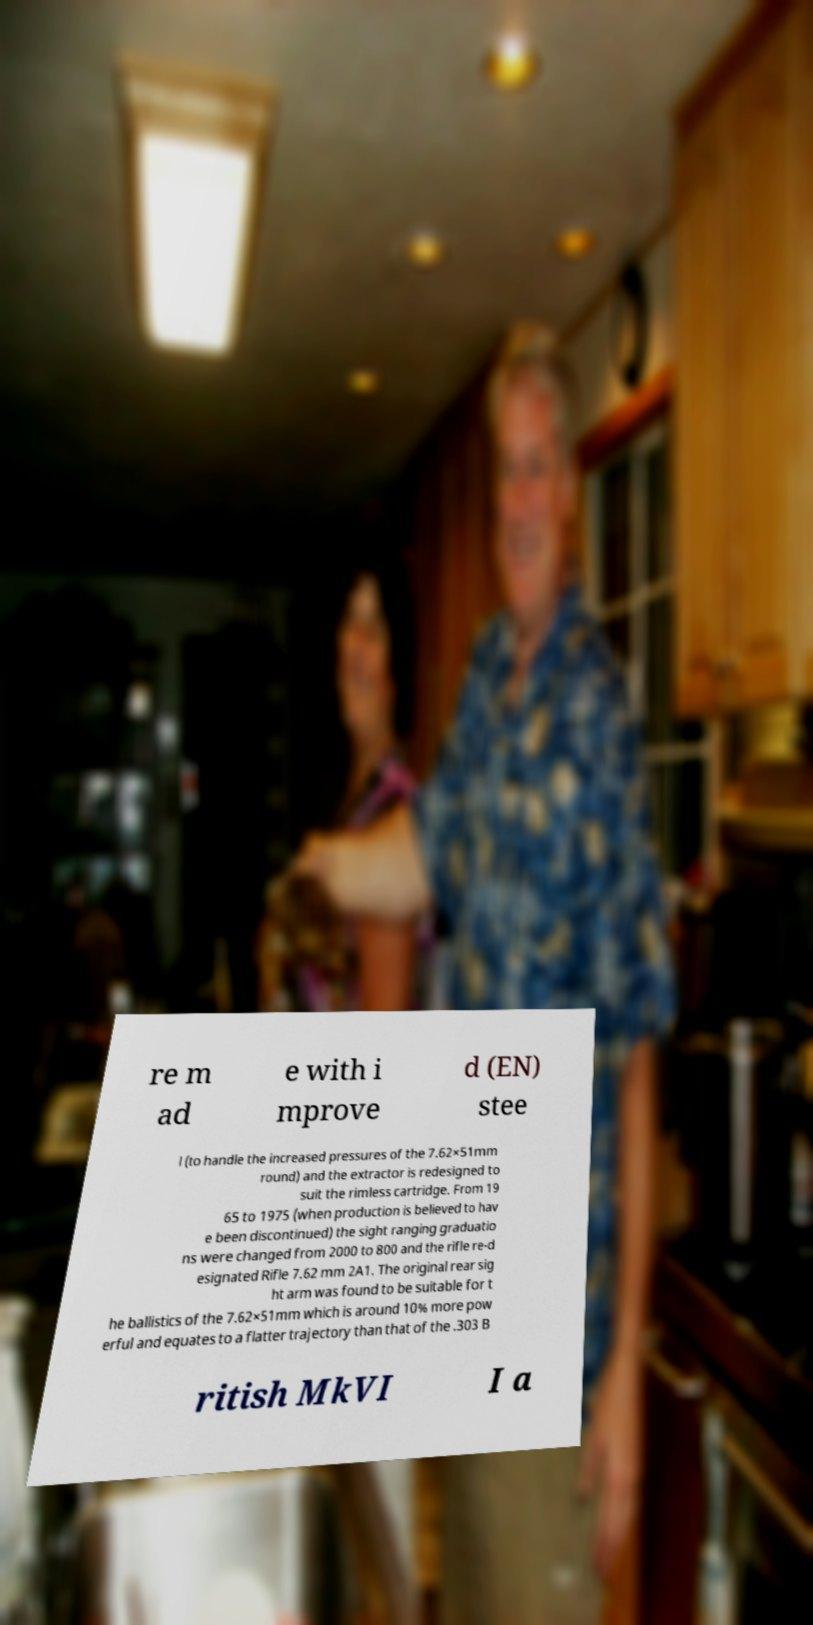Please identify and transcribe the text found in this image. re m ad e with i mprove d (EN) stee l (to handle the increased pressures of the 7.62×51mm round) and the extractor is redesigned to suit the rimless cartridge. From 19 65 to 1975 (when production is believed to hav e been discontinued) the sight ranging graduatio ns were changed from 2000 to 800 and the rifle re-d esignated Rifle 7.62 mm 2A1. The original rear sig ht arm was found to be suitable for t he ballistics of the 7.62×51mm which is around 10% more pow erful and equates to a flatter trajectory than that of the .303 B ritish MkVI I a 